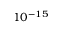Convert formula to latex. <formula><loc_0><loc_0><loc_500><loc_500>1 0 ^ { - 1 5 }</formula> 